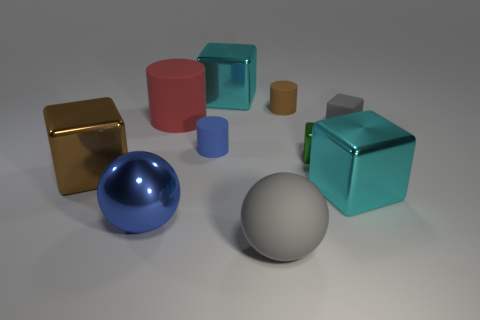Subtract all brown blocks. How many blocks are left? 4 Subtract all small green metal cubes. How many cubes are left? 4 Subtract all purple cylinders. Subtract all blue spheres. How many cylinders are left? 3 Subtract all cylinders. How many objects are left? 7 Add 8 red rubber things. How many red rubber things exist? 9 Subtract 0 cyan cylinders. How many objects are left? 10 Subtract all small matte cylinders. Subtract all small yellow things. How many objects are left? 8 Add 4 red matte cylinders. How many red matte cylinders are left? 5 